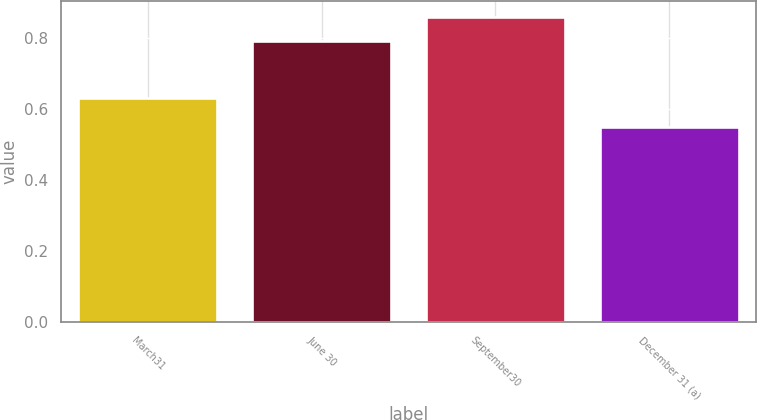Convert chart. <chart><loc_0><loc_0><loc_500><loc_500><bar_chart><fcel>March31<fcel>June 30<fcel>September30<fcel>December 31 (a)<nl><fcel>0.63<fcel>0.79<fcel>0.86<fcel>0.55<nl></chart> 